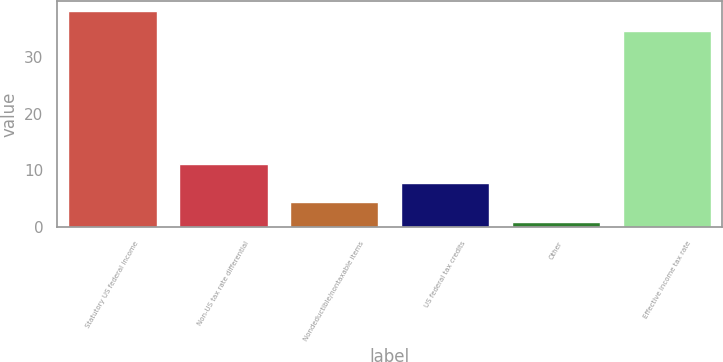<chart> <loc_0><loc_0><loc_500><loc_500><bar_chart><fcel>Statutory US federal income<fcel>Non-US tax rate differential<fcel>Nondeductible/nontaxable items<fcel>US federal tax credits<fcel>Other<fcel>Effective income tax rate<nl><fcel>38<fcel>11.2<fcel>4.4<fcel>7.8<fcel>1<fcel>34.6<nl></chart> 